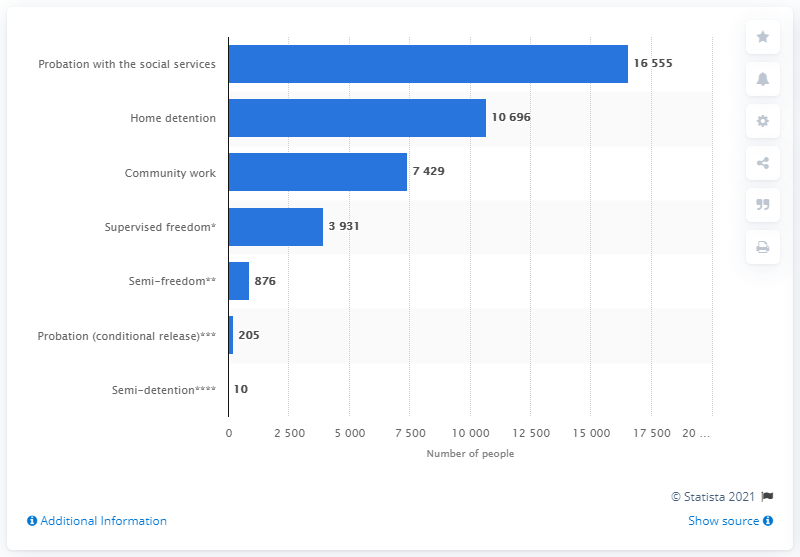Draw attention to some important aspects in this diagram. As of November 2018, there were approximately 16,555 individuals on probation in Italy. 